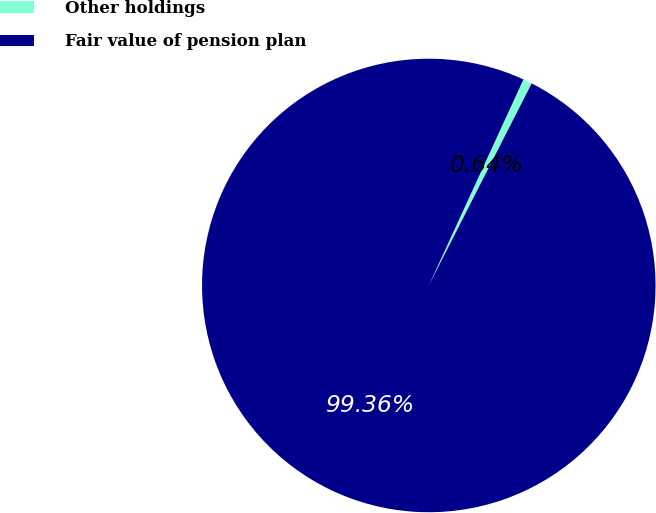<chart> <loc_0><loc_0><loc_500><loc_500><pie_chart><fcel>Other holdings<fcel>Fair value of pension plan<nl><fcel>0.64%<fcel>99.36%<nl></chart> 